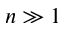<formula> <loc_0><loc_0><loc_500><loc_500>n \gg 1</formula> 